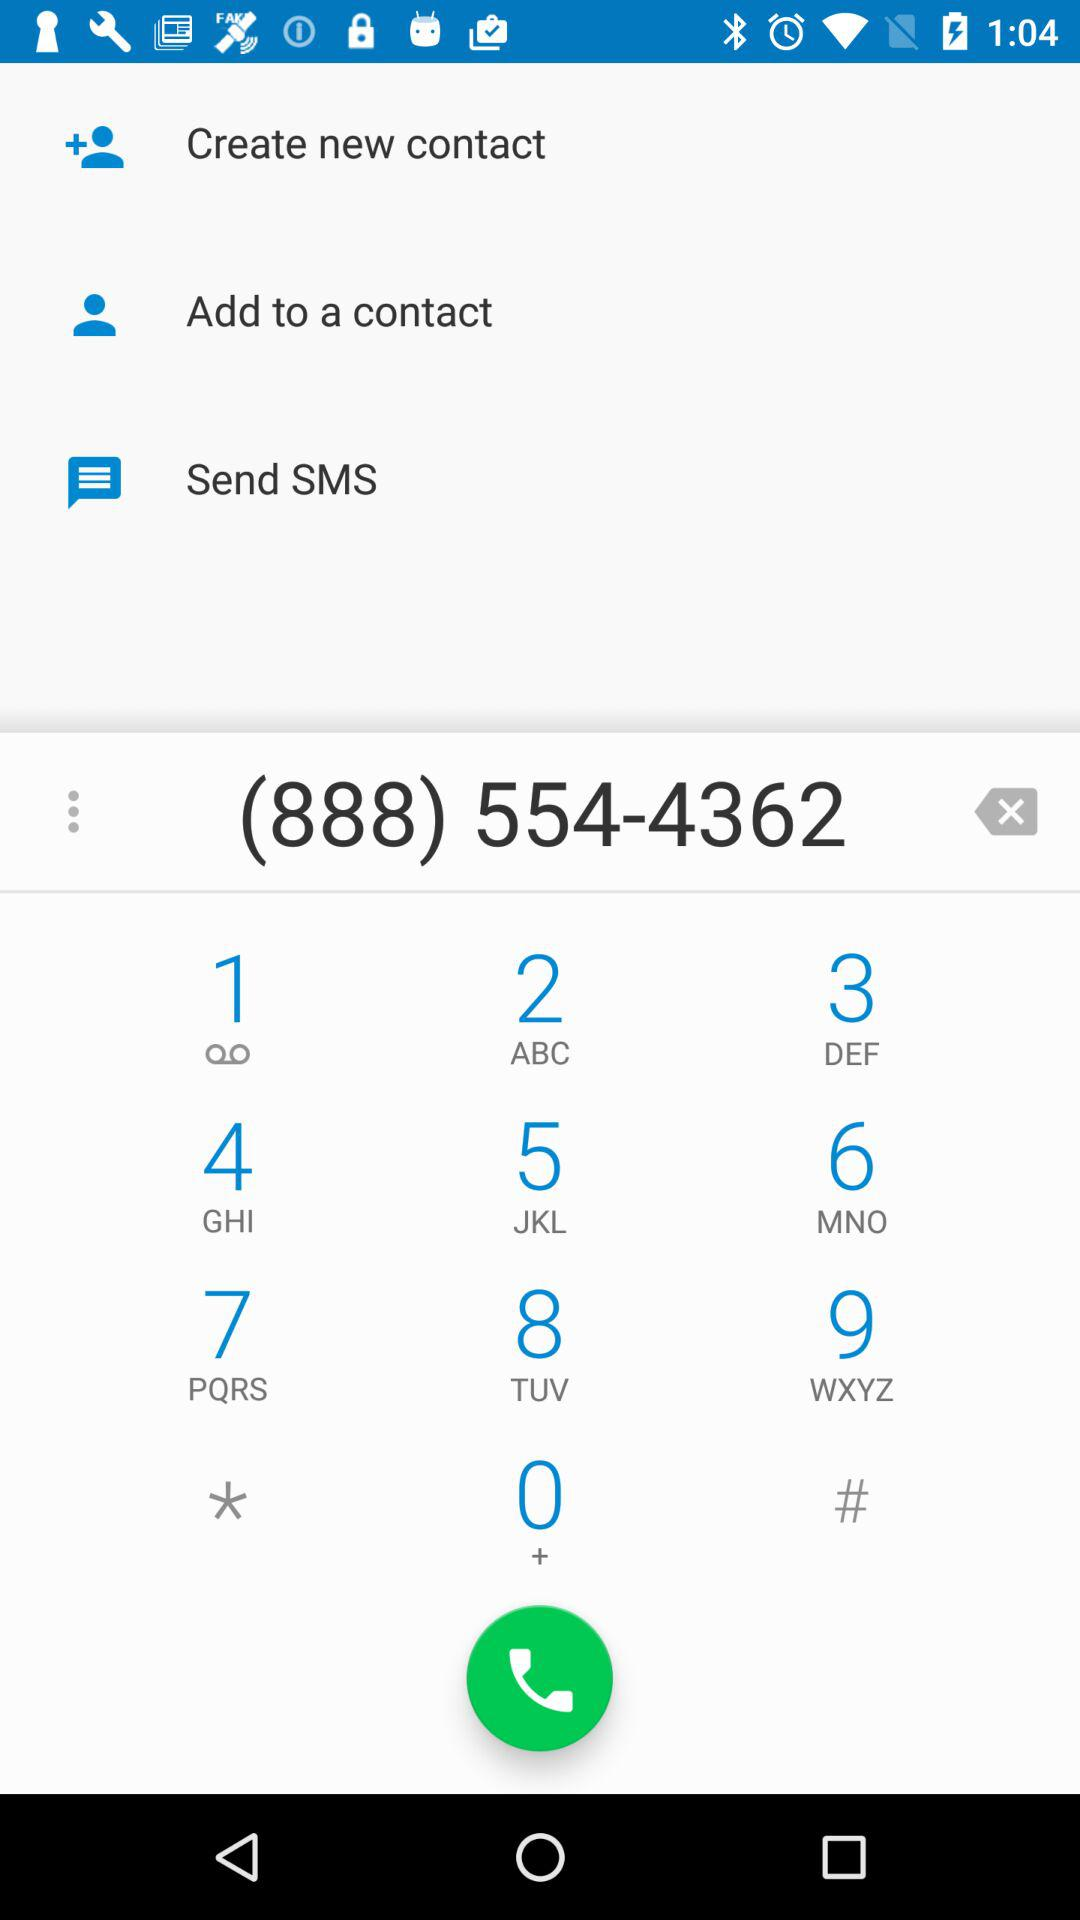What is the dialled number? The dialled number is 8885544362. 